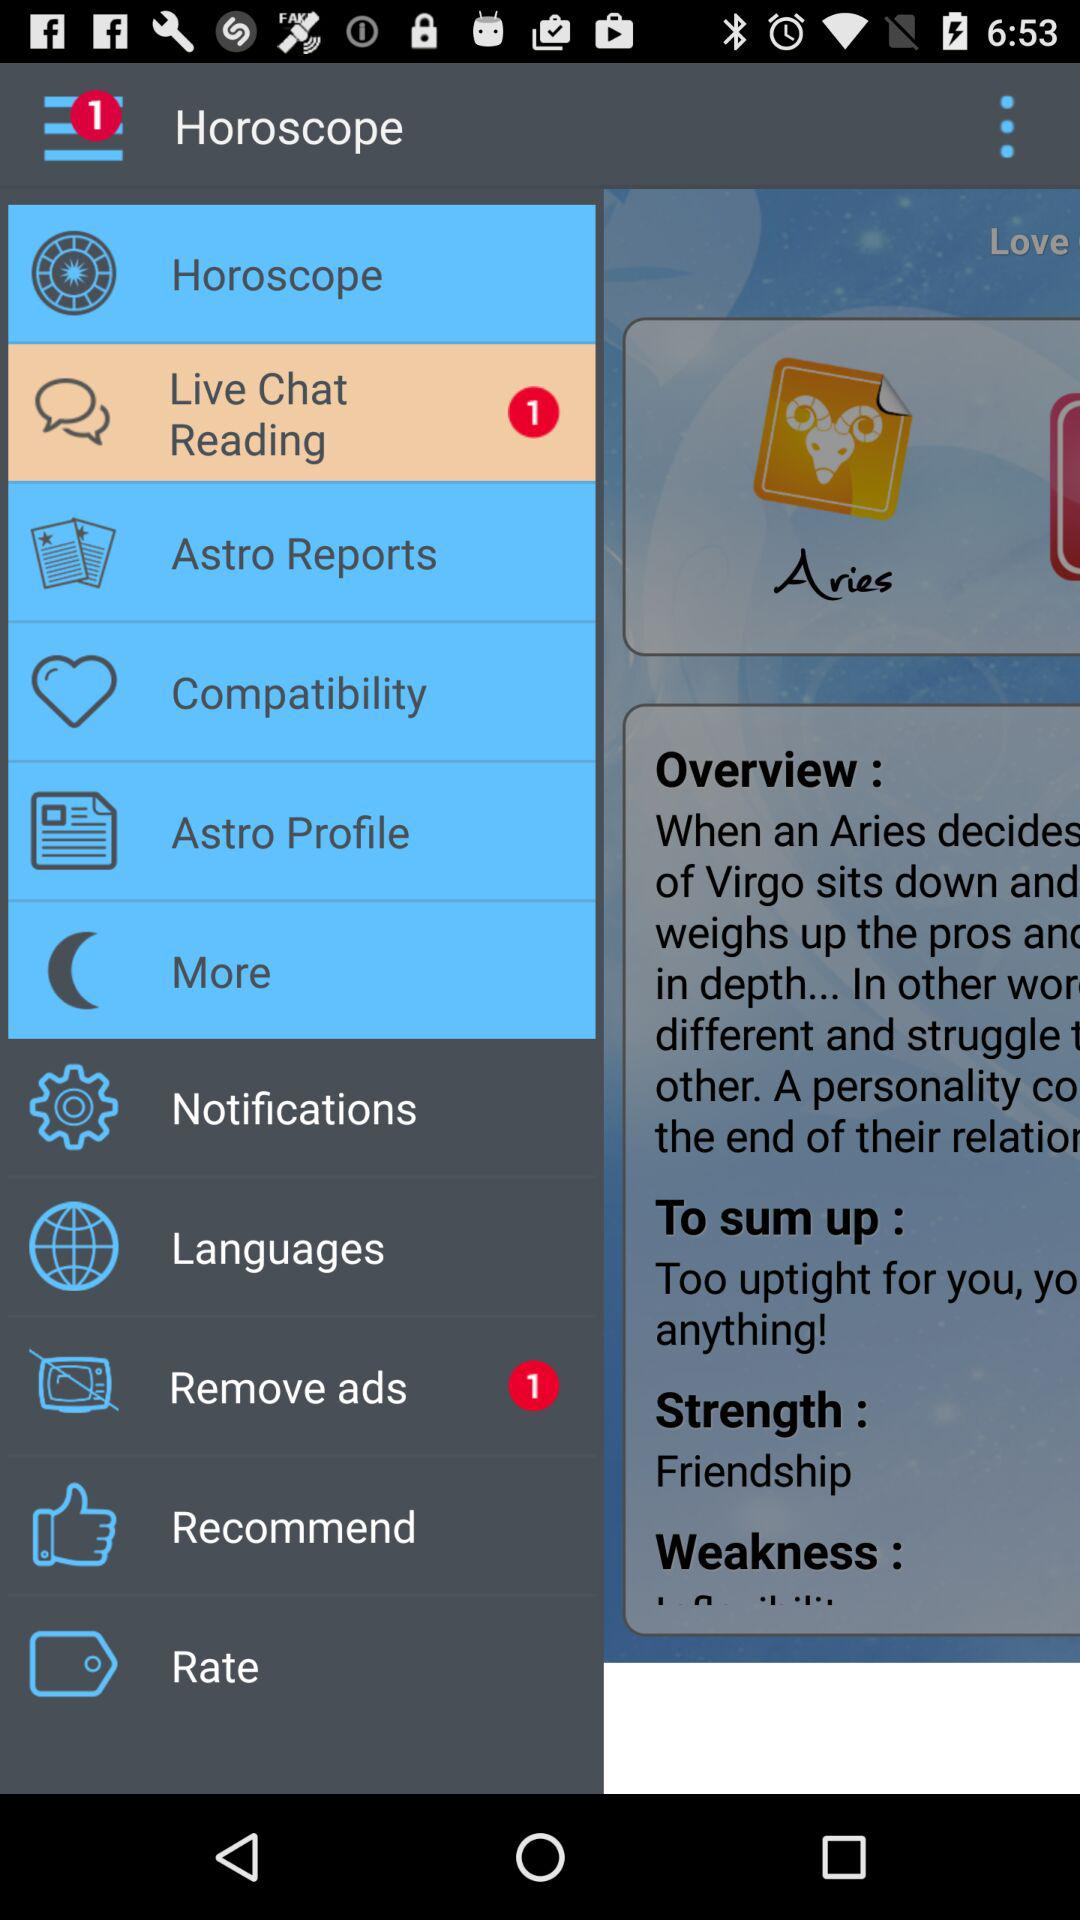How many notifications are there for "Remove ads"? There is 1 notification for "Remove ads". 